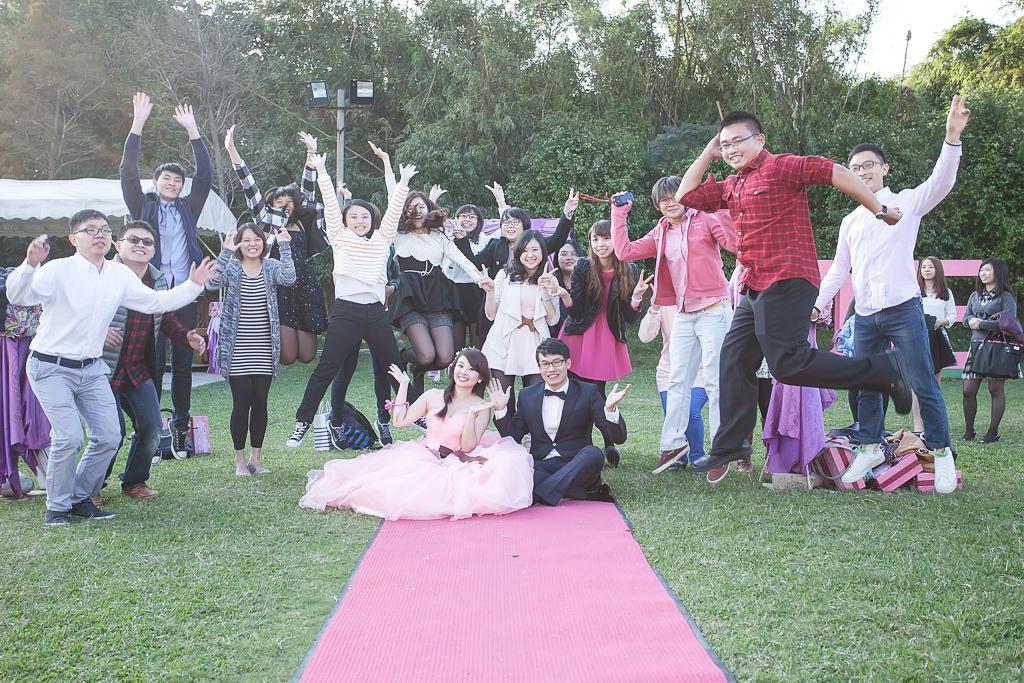Could you give a brief overview of what you see in this image? On the left side, there are persons smiling and slightly bending on the grass on the ground. In the middle, there is a woman and a man smiling and sitting on a pink color carpet. On the right side, there are persons smiling and jumping, there are person's smiling and standing, there is a white color tent, lights attached to the pole, there are trees and there is sky. 